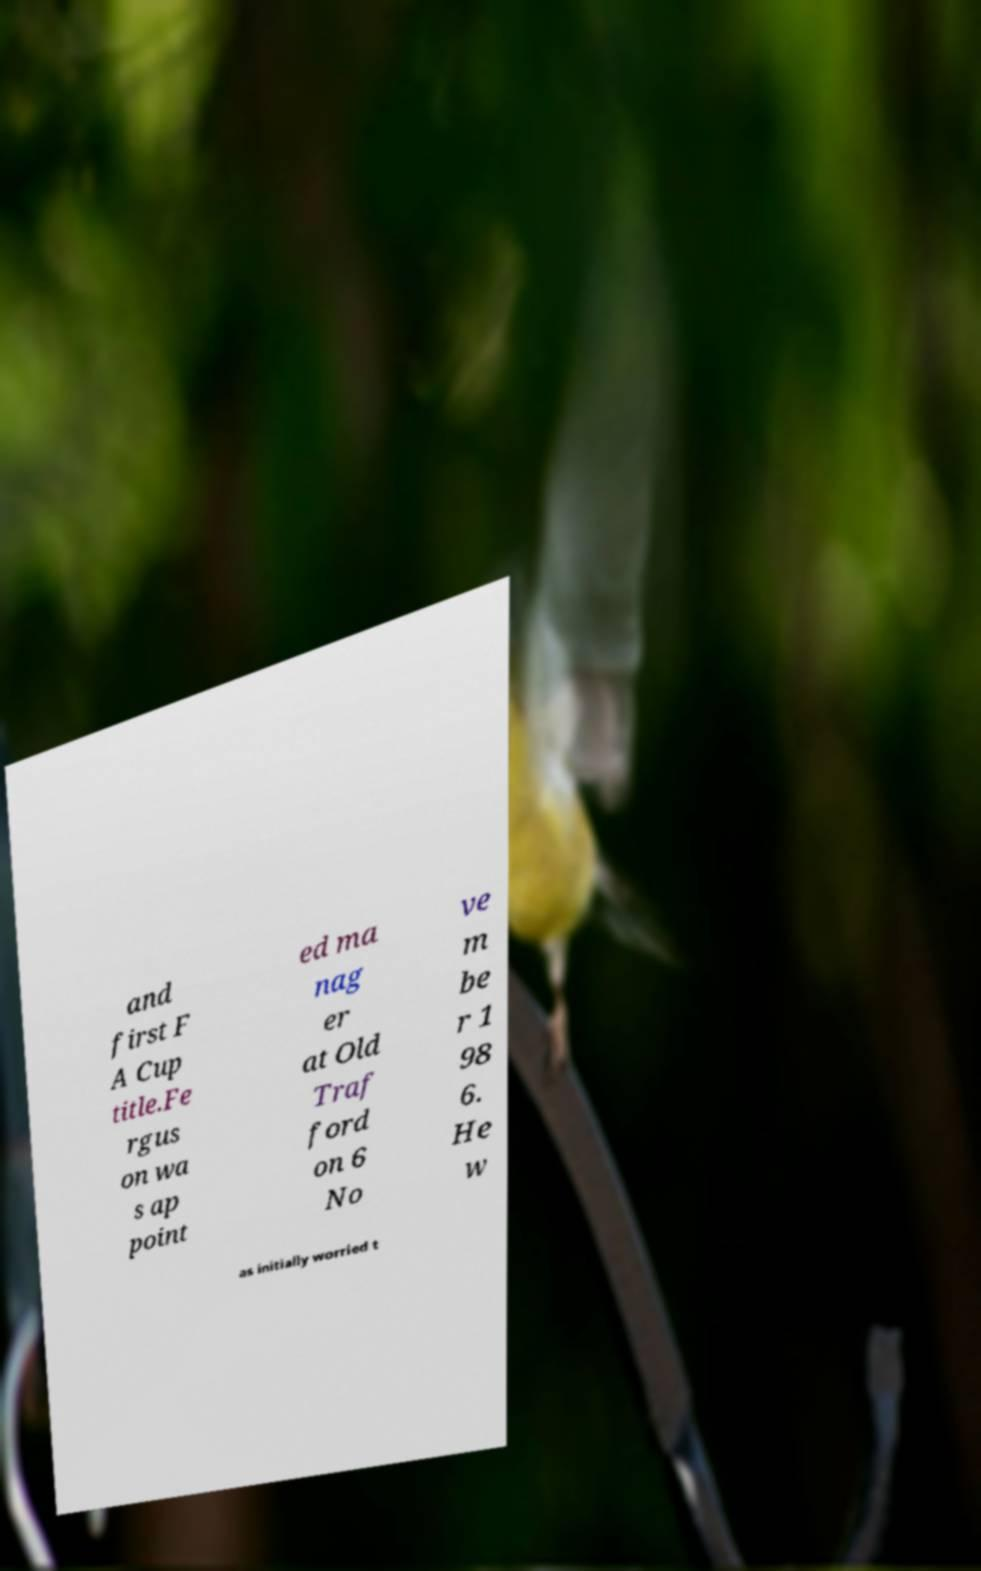I need the written content from this picture converted into text. Can you do that? and first F A Cup title.Fe rgus on wa s ap point ed ma nag er at Old Traf ford on 6 No ve m be r 1 98 6. He w as initially worried t 